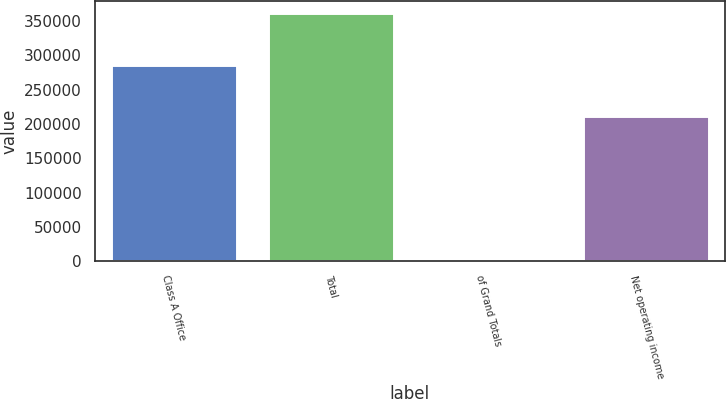<chart> <loc_0><loc_0><loc_500><loc_500><bar_chart><fcel>Class A Office<fcel>Total<fcel>of Grand Totals<fcel>Net operating income<nl><fcel>286568<fcel>361520<fcel>26.67<fcel>211601<nl></chart> 